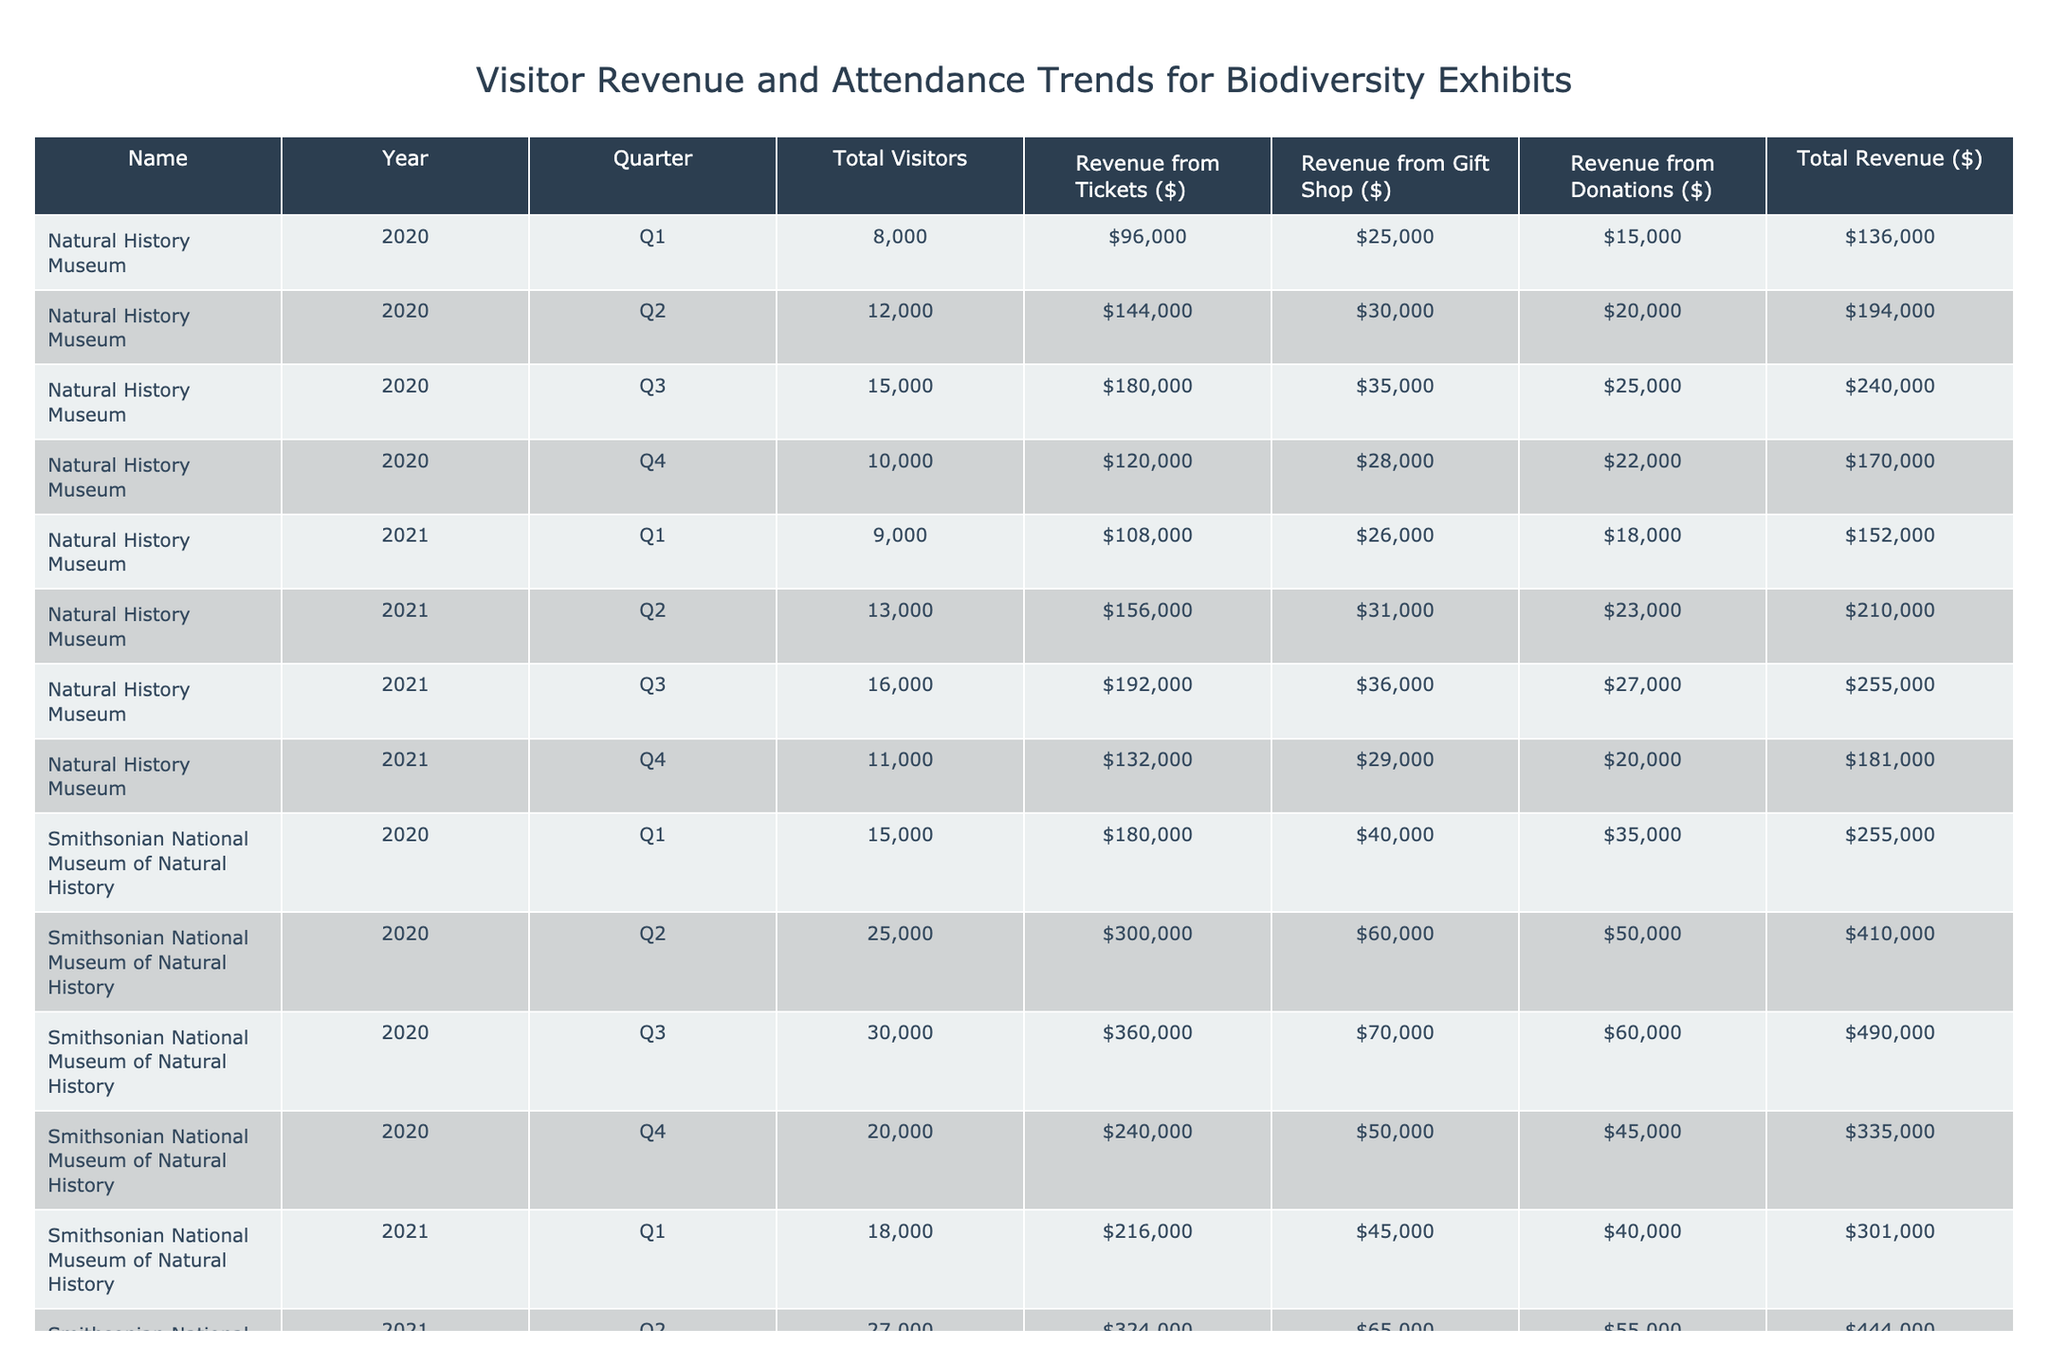What was the total revenue from ticket sales during Q2 2020 at the Smithsonian National Museum of Natural History? The table shows that in Q2 2020, the revenue from ticket sales at the Smithsonian National Museum of Natural History was $300,000.
Answer: $300,000 What was the total number of visitors for the Natural History Museum in 2021? By summing the total visitors for each quarter in 2021, we get 9,000 + 13,000 + 16,000 + 11,000 = 49,000 visitors.
Answer: 49,000 Did the Biodiversity Institute of Ontario have more total visitors in Q3 2021 than in Q4 2020? In Q3 2021, the total number of visitors was 12,000 compared to 8,000 in Q4 2020. Thus, it is true that Q3 2021 had more visitors.
Answer: Yes What was the average revenue from donations across all quarters in 2021 for the Smithsonian National Museum of Natural History? Adding the donation revenue for all quarters in 2021 gives $40,000 + $55,000 + $65,000 + $48,000 = $208,000. Dividing by the 4 quarters gives an average of $208,000 / 4 = $52,000.
Answer: $52,000 Which quarter in 2020 had the highest total revenue for the Biodiversity Institute of Ontario? By examining total revenue for each quarter in 2020, we see that Q3 2020 had the highest total revenue of $132,000.
Answer: Q3 2020 What was the percentage increase in total visitors from Q1 2020 to Q1 2021 at the Natural History Museum? The total visitors increased from 8,000 in Q1 2020 to 9,000 in Q1 2021, which is an increase of 1,000. The percentage increase is (1,000 / 8,000) * 100 = 12.5%.
Answer: 12.5% Was the total revenue for the Smithsonian National Museum of Natural History consistently above $300,000 in all quarters of 2021? The total revenue for 2021 quarters was $301,000, $444,000, $524,000, and $379,000. Since $301,000 is lower than $300,000, it was not consistently above that amount.
Answer: No Which museum had the highest total revenue in Q1 2020? By comparing the total revenue for Q1 2020, the Smithsonian National Museum of Natural History had $255,000, while the Natural History Museum had $136,000 and the Biodiversity Institute of Ontario had $65,000. Thus, the Smithsonian National Museum had the highest revenue.
Answer: Smithsonian National Museum of Natural History 